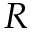Convert formula to latex. <formula><loc_0><loc_0><loc_500><loc_500>R</formula> 